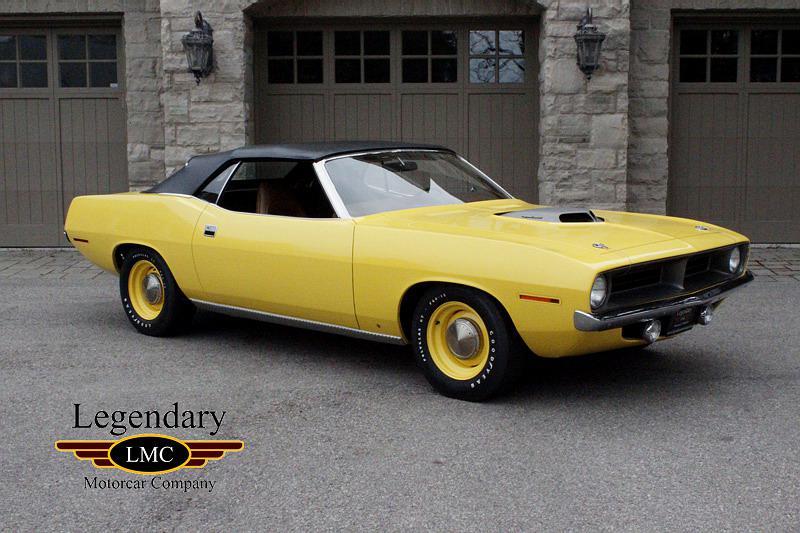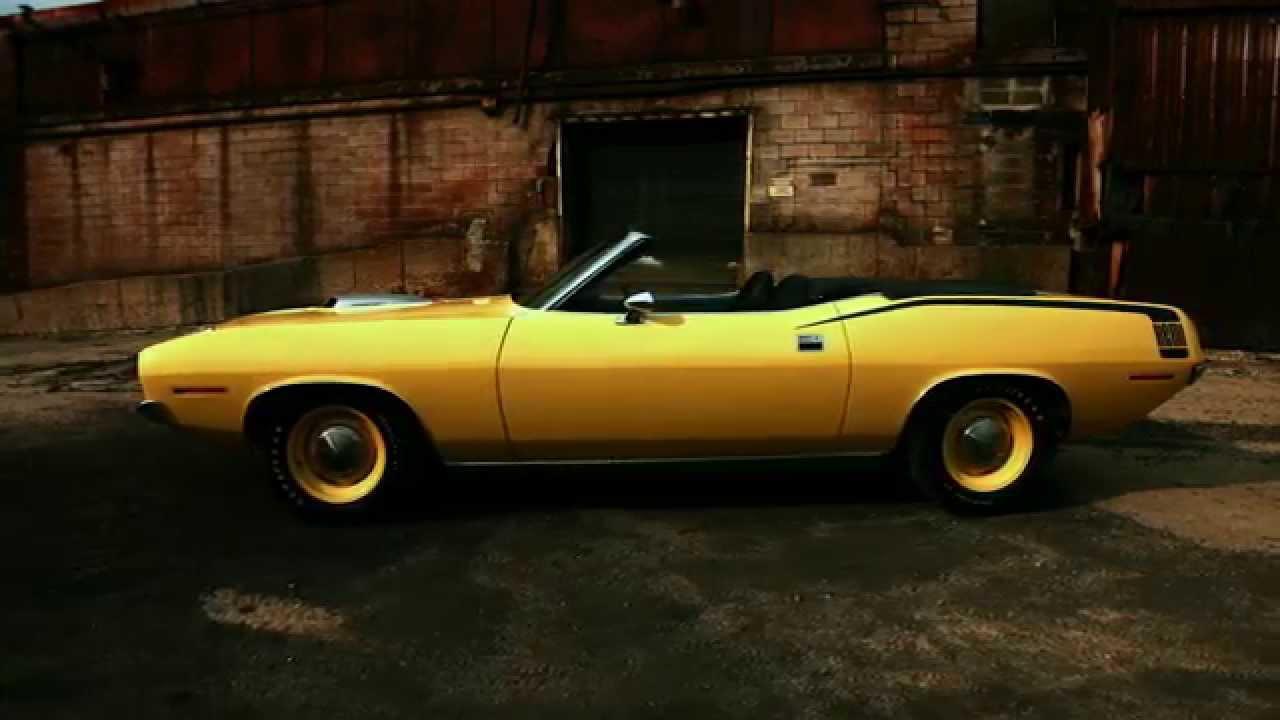The first image is the image on the left, the second image is the image on the right. Examine the images to the left and right. Is the description "At least one image shows a car with a white interior and white decal over the rear fender." accurate? Answer yes or no. No. 